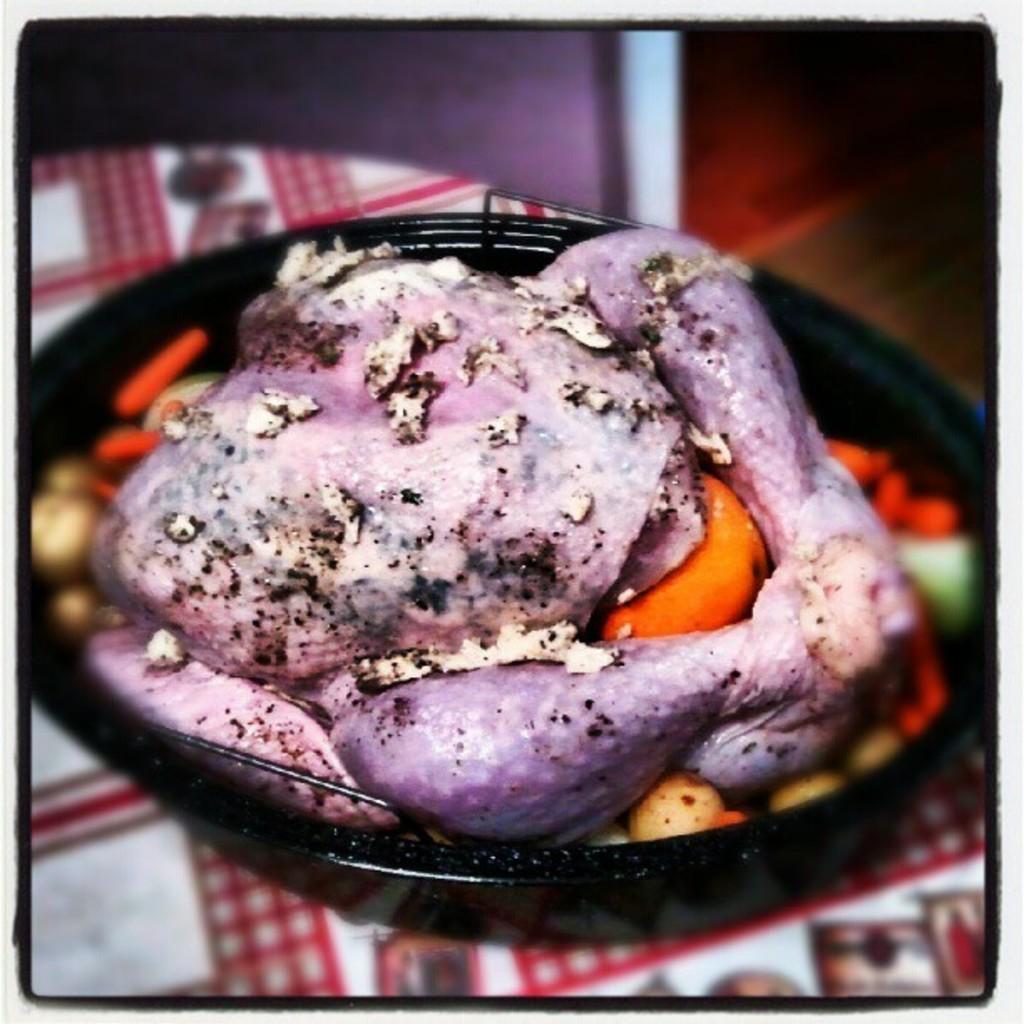Could you give a brief overview of what you see in this image? It is a chicken in a black color pan. 